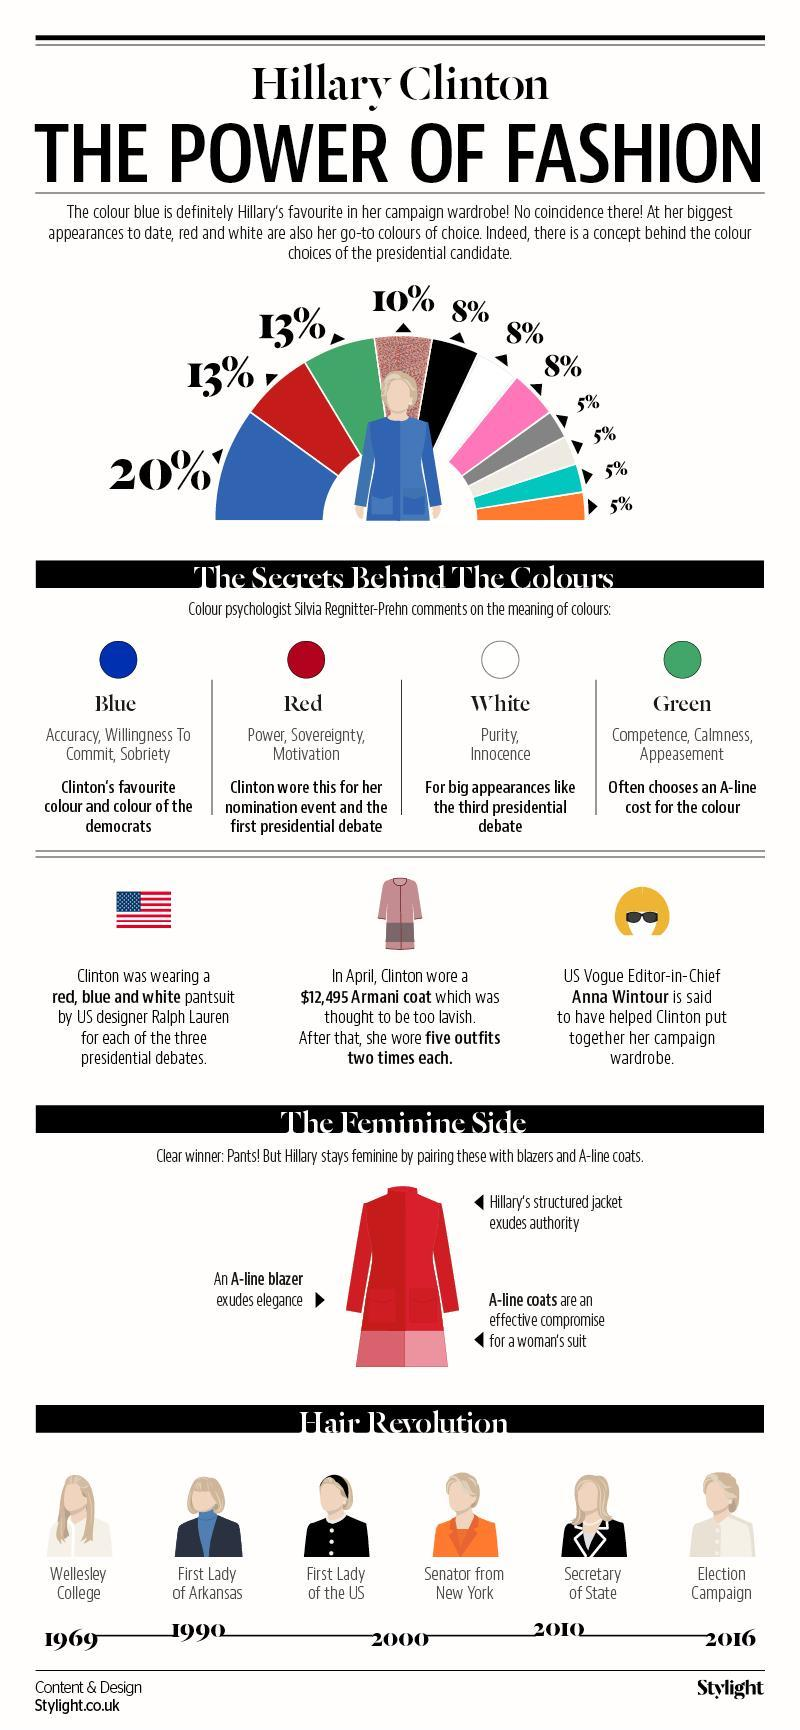What percent of Hillary's dress has black and white?
Answer the question with a short phrase. 16% What does the colour worn by Hillary for third presidential debate signify? Purity, Innocence What colours are there in the American flag? red, blue and white What percent of Hillary's dress choices have blue? 20% Under which position did Hillary wear her hair long? Wellesley College 